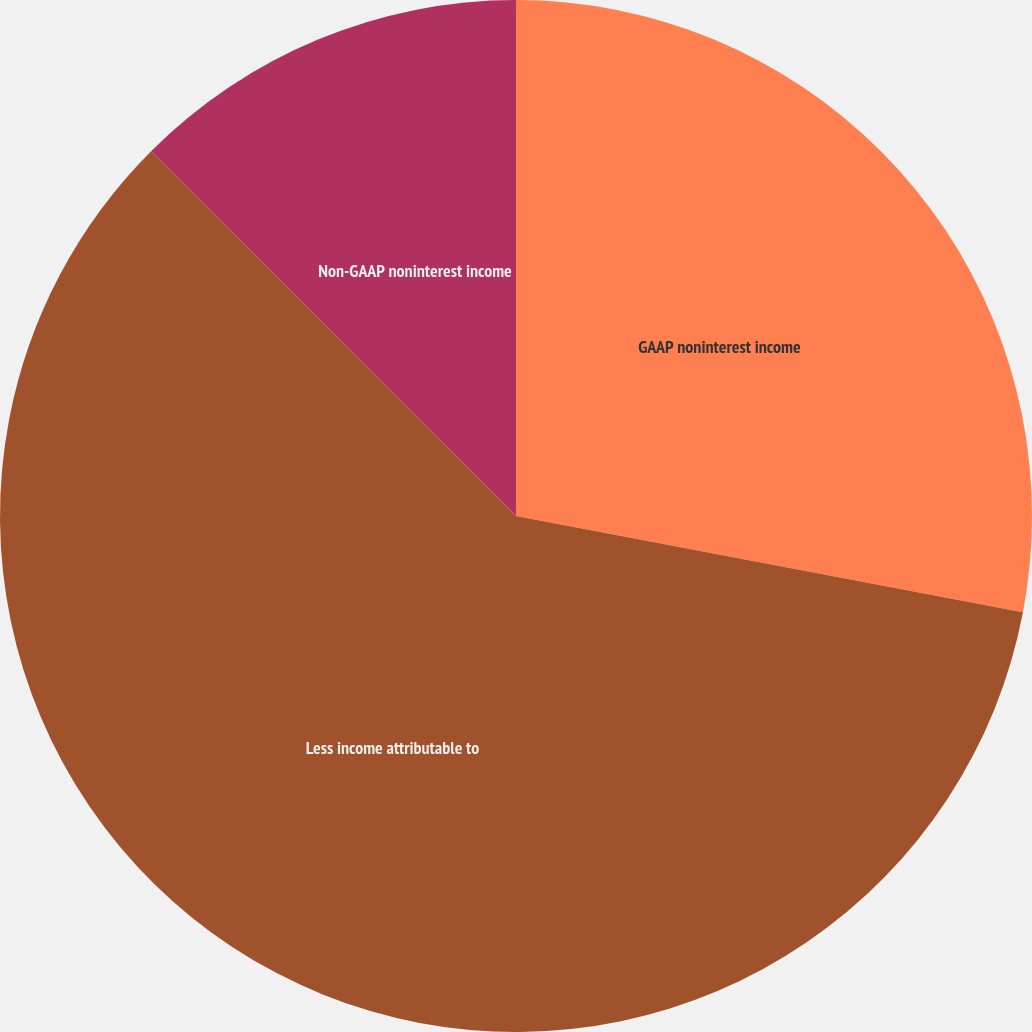<chart> <loc_0><loc_0><loc_500><loc_500><pie_chart><fcel>GAAP noninterest income<fcel>Less income attributable to<fcel>Non-GAAP noninterest income<nl><fcel>27.99%<fcel>59.51%<fcel>12.5%<nl></chart> 